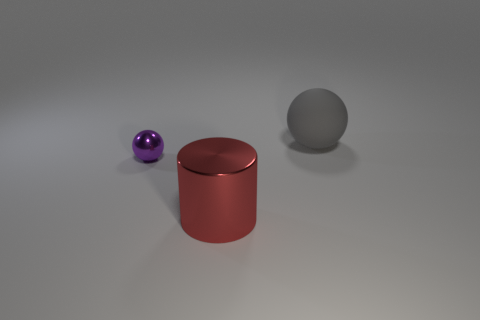Add 1 matte spheres. How many objects exist? 4 Subtract all cylinders. How many objects are left? 2 Subtract 1 balls. How many balls are left? 1 Add 2 big metallic cylinders. How many big metallic cylinders exist? 3 Subtract all purple spheres. How many spheres are left? 1 Subtract 0 red balls. How many objects are left? 3 Subtract all yellow spheres. Subtract all cyan cubes. How many spheres are left? 2 Subtract all gray matte things. Subtract all small red matte things. How many objects are left? 2 Add 2 red objects. How many red objects are left? 3 